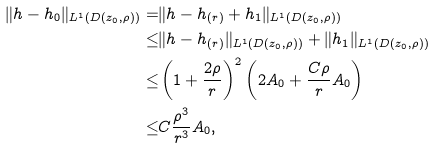<formula> <loc_0><loc_0><loc_500><loc_500>\| h - h _ { 0 } \| _ { L ^ { 1 } ( D ( z _ { 0 } , \rho ) ) } = & \| h - h _ { ( r ) } + h _ { 1 } \| _ { L ^ { 1 } ( D ( z _ { 0 } , \rho ) ) } \\ \leq & \| h - h _ { ( r ) } \| _ { L ^ { 1 } ( D ( z _ { 0 } , \rho ) ) } + \| h _ { 1 } \| _ { L ^ { 1 } ( D ( z _ { 0 } , \rho ) ) } \\ \leq & \left ( 1 + \frac { 2 \rho } { r } \right ) ^ { 2 } \left ( 2 A _ { 0 } + \frac { C \rho } { r } A _ { 0 } \right ) \\ \leq & C \frac { \rho ^ { 3 } } { r ^ { 3 } } A _ { 0 } ,</formula> 